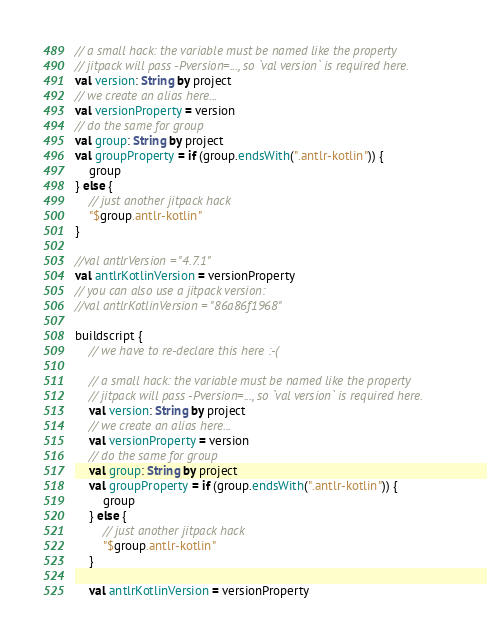<code> <loc_0><loc_0><loc_500><loc_500><_Kotlin_>// a small hack: the variable must be named like the property
// jitpack will pass -Pversion=..., so `val version` is required here.
val version: String by project
// we create an alias here...
val versionProperty = version
// do the same for group
val group: String by project
val groupProperty = if (group.endsWith(".antlr-kotlin")) {
    group
} else {
    // just another jitpack hack
    "$group.antlr-kotlin"
}

//val antlrVersion = "4.7.1"
val antlrKotlinVersion = versionProperty
// you can also use a jitpack version:
//val antlrKotlinVersion = "86a86f1968"

buildscript {
    // we have to re-declare this here :-(

    // a small hack: the variable must be named like the property
    // jitpack will pass -Pversion=..., so `val version` is required here.
    val version: String by project
    // we create an alias here...
    val versionProperty = version
    // do the same for group
    val group: String by project
    val groupProperty = if (group.endsWith(".antlr-kotlin")) {
        group
    } else {
        // just another jitpack hack
        "$group.antlr-kotlin"
    }

    val antlrKotlinVersion = versionProperty</code> 